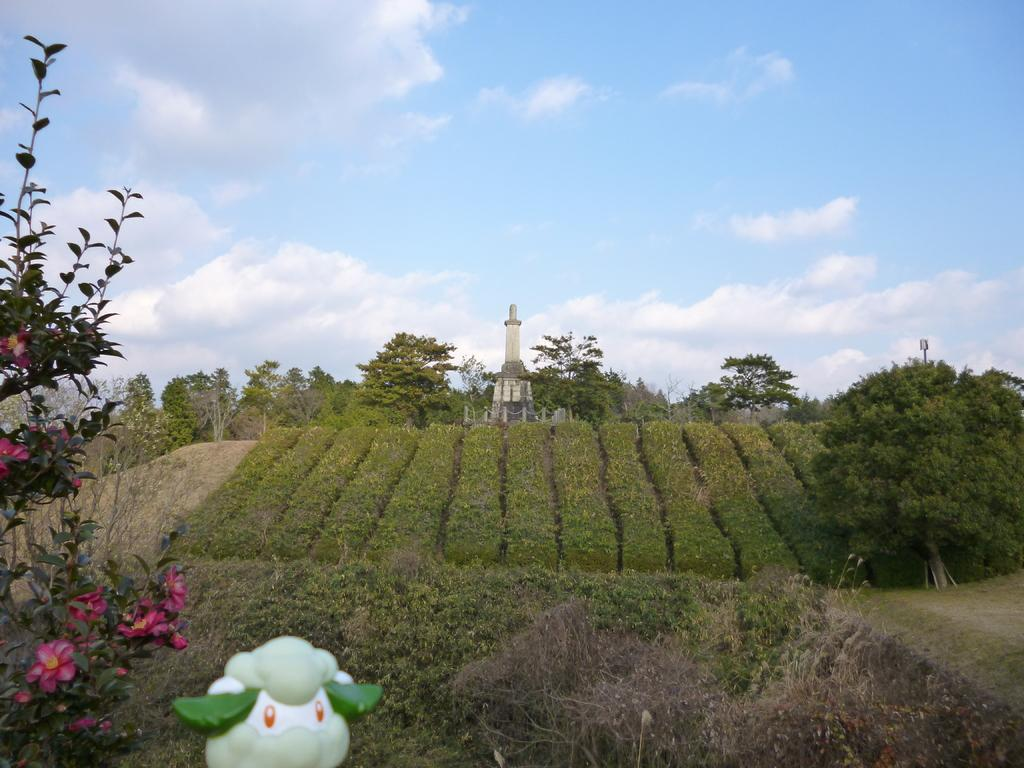What is the main structure in the image? There is a tower in the image. What are the barrier poles used for in the image? The barrier poles are present in the image to restrict access or movement. What type of vegetation can be seen in the image? There are trees, plants, and flowers visible in the image. What is the garden maze used for in the image? The garden maze is a recreational feature in the image, providing a space for exploration and leisure. What is visible in the sky in the image? The sky is visible in the image, with clouds present. Can you see any crooks or cobwebs in the image? There are no crooks or cobwebs present in the image. Are there any instances of biting or being bitten in the image? There is no indication of biting or being bitten in the image. 